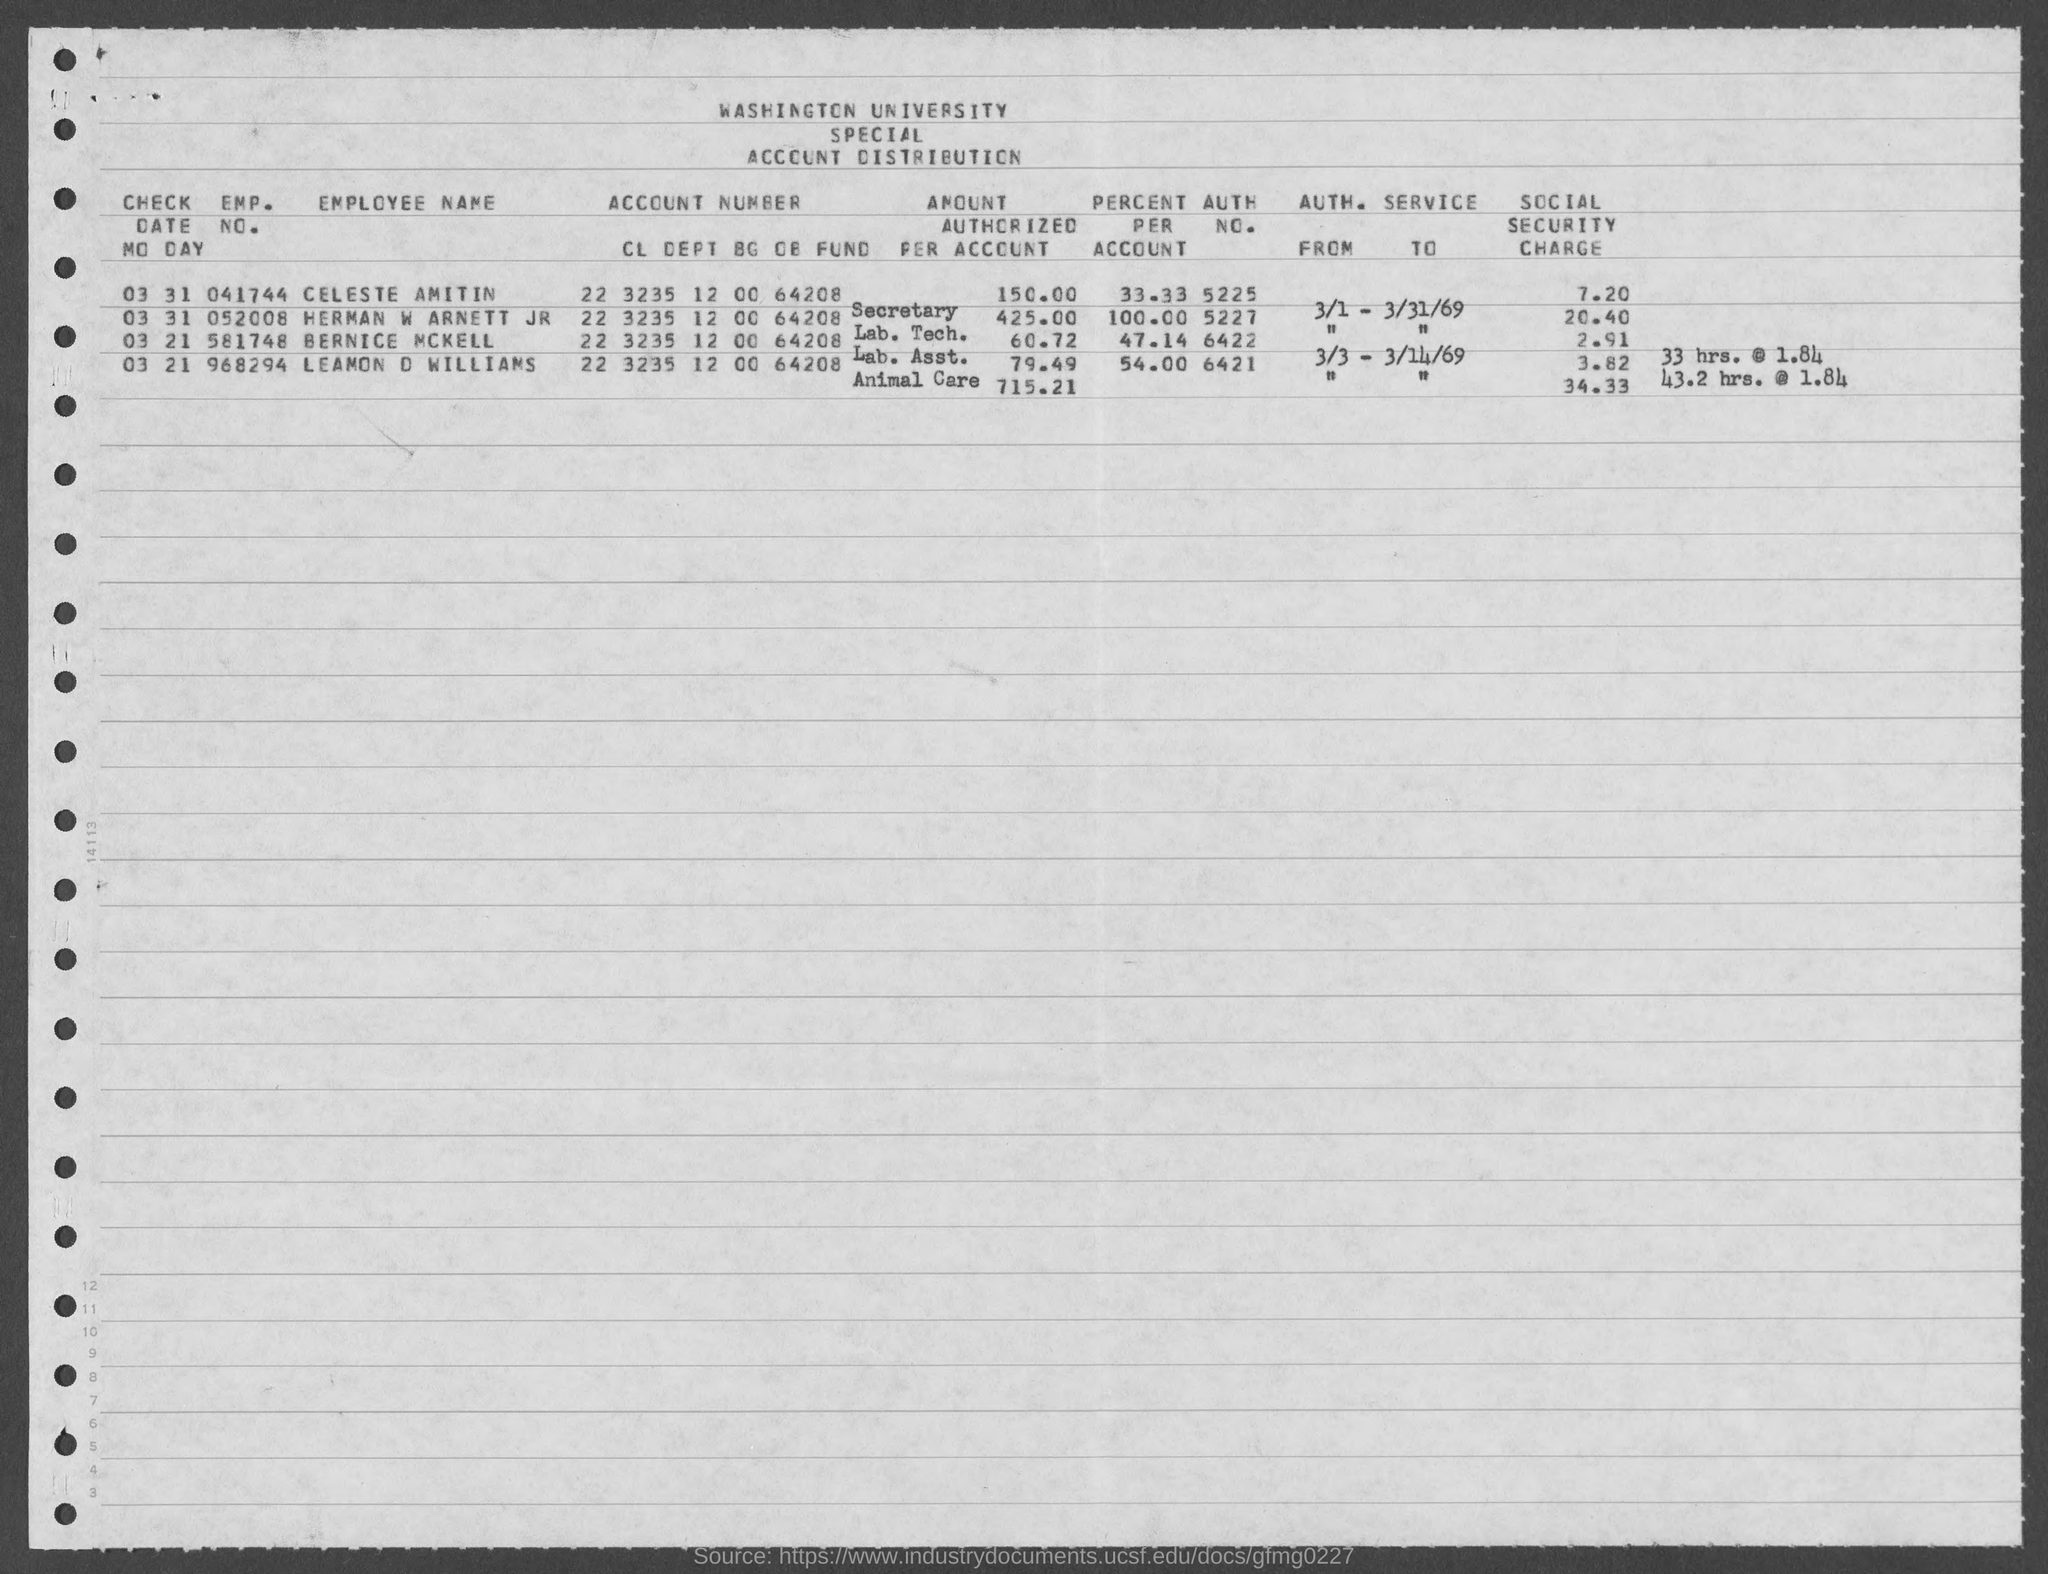What is the emp. no. of celeste amitin ?
Ensure brevity in your answer.  041744. What is the emp. no. of  herman w arnett jr?
Your answer should be very brief. 052008. What is the emp. no. of bernice mckell ?
Give a very brief answer. 581748. What is the auth. no. of celeste amitin ?
Ensure brevity in your answer.  5225. What is the auth. no. of herman w arnett jr?
Your answer should be very brief. 5227. What is the auth. no. of bernice mckell?
Give a very brief answer. 6422. What is the auth. no. of leamon d williams?
Your response must be concise. 6421. What is the social security charge of leamon d williams ?
Offer a very short reply. 3.82. What is the social security charge of bernice mckell?
Keep it short and to the point. 2.91. 